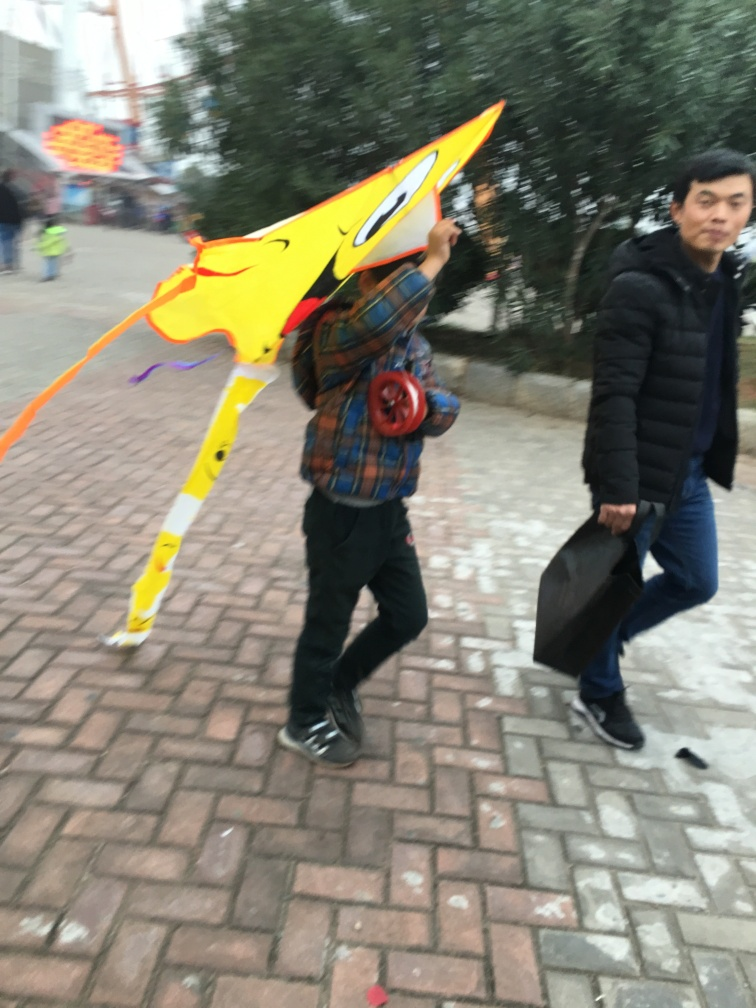Is the background blurry? Yes, the background shows considerable motion blur, providing a sense of movement and making the subject in the foreground, which is in sharper focus, stand out. 